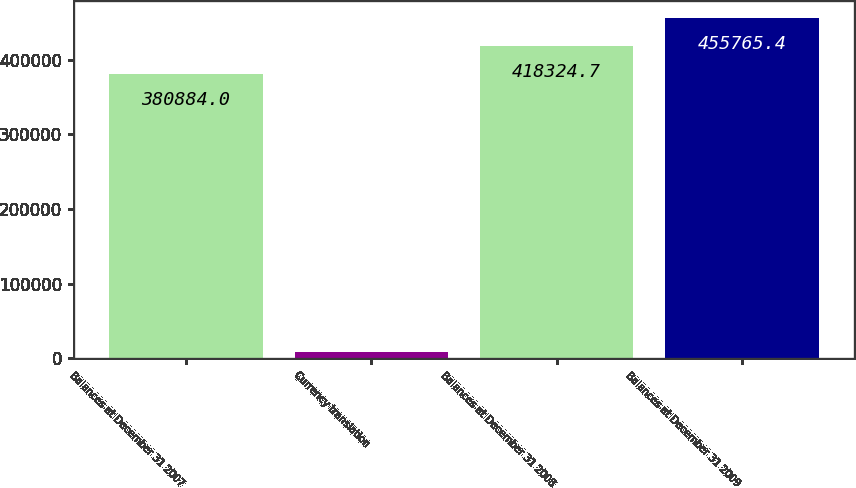Convert chart to OTSL. <chart><loc_0><loc_0><loc_500><loc_500><bar_chart><fcel>Balances at December 31 2007<fcel>Currency translation<fcel>Balances at December 31 2008<fcel>Balances at December 31 2009<nl><fcel>380884<fcel>8800<fcel>418325<fcel>455765<nl></chart> 